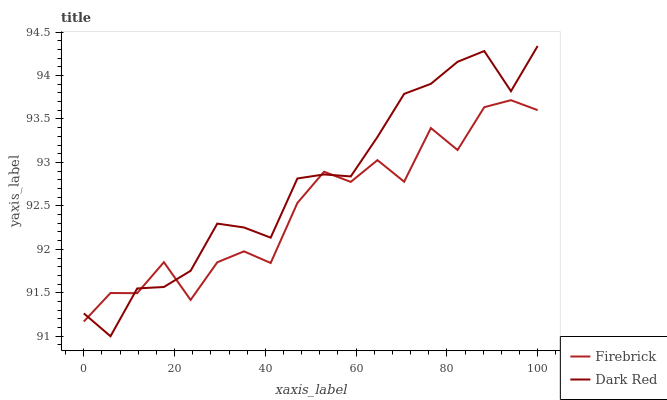Does Firebrick have the minimum area under the curve?
Answer yes or no. Yes. Does Dark Red have the maximum area under the curve?
Answer yes or no. Yes. Does Firebrick have the maximum area under the curve?
Answer yes or no. No. Is Dark Red the smoothest?
Answer yes or no. Yes. Is Firebrick the roughest?
Answer yes or no. Yes. Is Firebrick the smoothest?
Answer yes or no. No. Does Dark Red have the lowest value?
Answer yes or no. Yes. Does Firebrick have the lowest value?
Answer yes or no. No. Does Dark Red have the highest value?
Answer yes or no. Yes. Does Firebrick have the highest value?
Answer yes or no. No. Does Firebrick intersect Dark Red?
Answer yes or no. Yes. Is Firebrick less than Dark Red?
Answer yes or no. No. Is Firebrick greater than Dark Red?
Answer yes or no. No. 